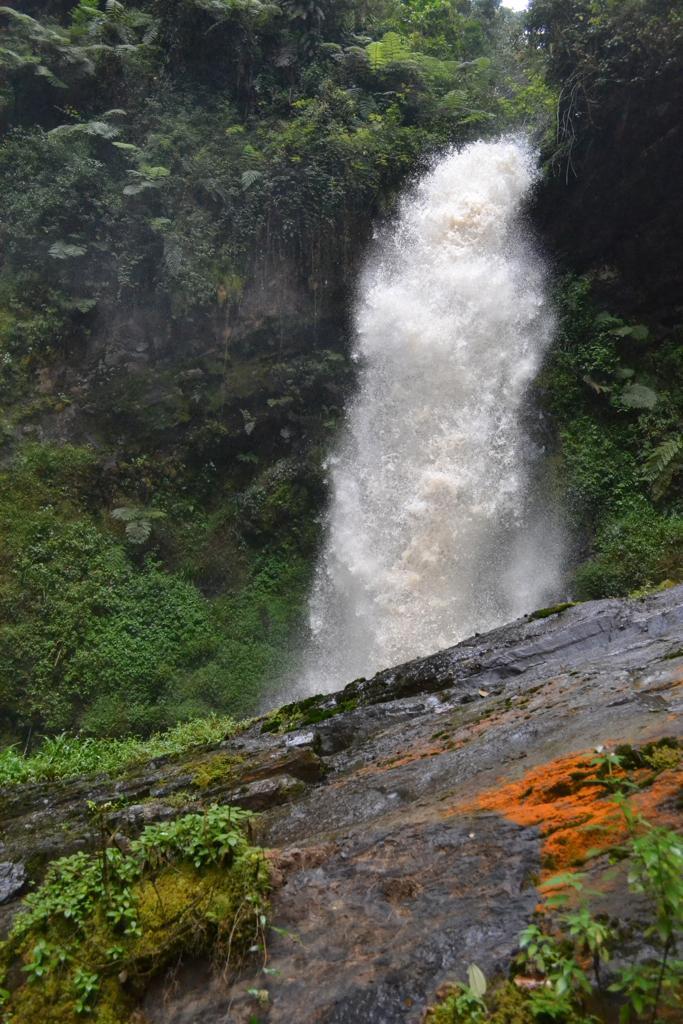Describe this image in one or two sentences. In this image we can see a waterfall, here is the water, there are trees, here are the plants, here is the rock. 